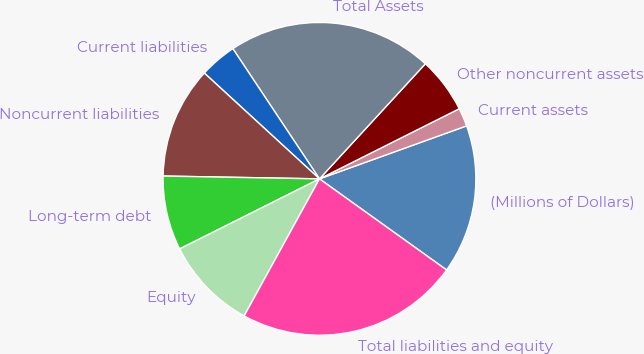Convert chart. <chart><loc_0><loc_0><loc_500><loc_500><pie_chart><fcel>(Millions of Dollars)<fcel>Current assets<fcel>Other noncurrent assets<fcel>Total Assets<fcel>Current liabilities<fcel>Noncurrent liabilities<fcel>Long-term debt<fcel>Equity<fcel>Total liabilities and equity<nl><fcel>15.4%<fcel>1.9%<fcel>5.76%<fcel>21.18%<fcel>3.83%<fcel>11.54%<fcel>7.68%<fcel>9.61%<fcel>23.1%<nl></chart> 